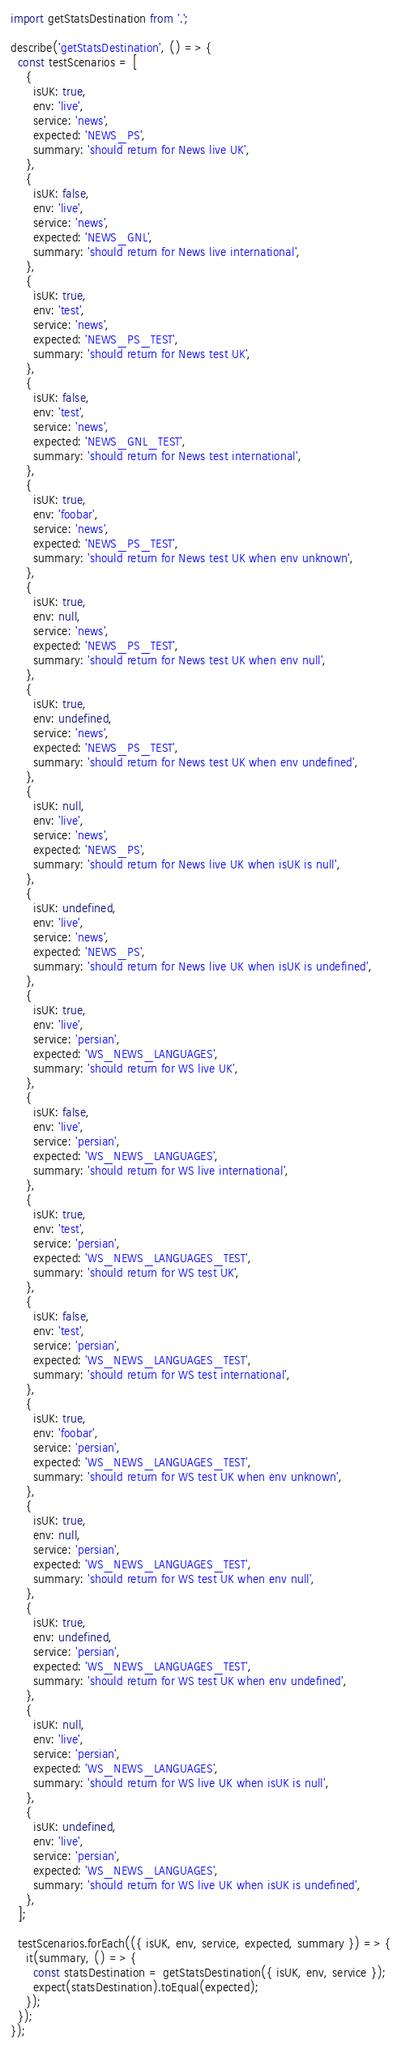Convert code to text. <code><loc_0><loc_0><loc_500><loc_500><_JavaScript_>import getStatsDestination from '.';

describe('getStatsDestination', () => {
  const testScenarios = [
    {
      isUK: true,
      env: 'live',
      service: 'news',
      expected: 'NEWS_PS',
      summary: 'should return for News live UK',
    },
    {
      isUK: false,
      env: 'live',
      service: 'news',
      expected: 'NEWS_GNL',
      summary: 'should return for News live international',
    },
    {
      isUK: true,
      env: 'test',
      service: 'news',
      expected: 'NEWS_PS_TEST',
      summary: 'should return for News test UK',
    },
    {
      isUK: false,
      env: 'test',
      service: 'news',
      expected: 'NEWS_GNL_TEST',
      summary: 'should return for News test international',
    },
    {
      isUK: true,
      env: 'foobar',
      service: 'news',
      expected: 'NEWS_PS_TEST',
      summary: 'should return for News test UK when env unknown',
    },
    {
      isUK: true,
      env: null,
      service: 'news',
      expected: 'NEWS_PS_TEST',
      summary: 'should return for News test UK when env null',
    },
    {
      isUK: true,
      env: undefined,
      service: 'news',
      expected: 'NEWS_PS_TEST',
      summary: 'should return for News test UK when env undefined',
    },
    {
      isUK: null,
      env: 'live',
      service: 'news',
      expected: 'NEWS_PS',
      summary: 'should return for News live UK when isUK is null',
    },
    {
      isUK: undefined,
      env: 'live',
      service: 'news',
      expected: 'NEWS_PS',
      summary: 'should return for News live UK when isUK is undefined',
    },
    {
      isUK: true,
      env: 'live',
      service: 'persian',
      expected: 'WS_NEWS_LANGUAGES',
      summary: 'should return for WS live UK',
    },
    {
      isUK: false,
      env: 'live',
      service: 'persian',
      expected: 'WS_NEWS_LANGUAGES',
      summary: 'should return for WS live international',
    },
    {
      isUK: true,
      env: 'test',
      service: 'persian',
      expected: 'WS_NEWS_LANGUAGES_TEST',
      summary: 'should return for WS test UK',
    },
    {
      isUK: false,
      env: 'test',
      service: 'persian',
      expected: 'WS_NEWS_LANGUAGES_TEST',
      summary: 'should return for WS test international',
    },
    {
      isUK: true,
      env: 'foobar',
      service: 'persian',
      expected: 'WS_NEWS_LANGUAGES_TEST',
      summary: 'should return for WS test UK when env unknown',
    },
    {
      isUK: true,
      env: null,
      service: 'persian',
      expected: 'WS_NEWS_LANGUAGES_TEST',
      summary: 'should return for WS test UK when env null',
    },
    {
      isUK: true,
      env: undefined,
      service: 'persian',
      expected: 'WS_NEWS_LANGUAGES_TEST',
      summary: 'should return for WS test UK when env undefined',
    },
    {
      isUK: null,
      env: 'live',
      service: 'persian',
      expected: 'WS_NEWS_LANGUAGES',
      summary: 'should return for WS live UK when isUK is null',
    },
    {
      isUK: undefined,
      env: 'live',
      service: 'persian',
      expected: 'WS_NEWS_LANGUAGES',
      summary: 'should return for WS live UK when isUK is undefined',
    },
  ];

  testScenarios.forEach(({ isUK, env, service, expected, summary }) => {
    it(summary, () => {
      const statsDestination = getStatsDestination({ isUK, env, service });
      expect(statsDestination).toEqual(expected);
    });
  });
});
</code> 